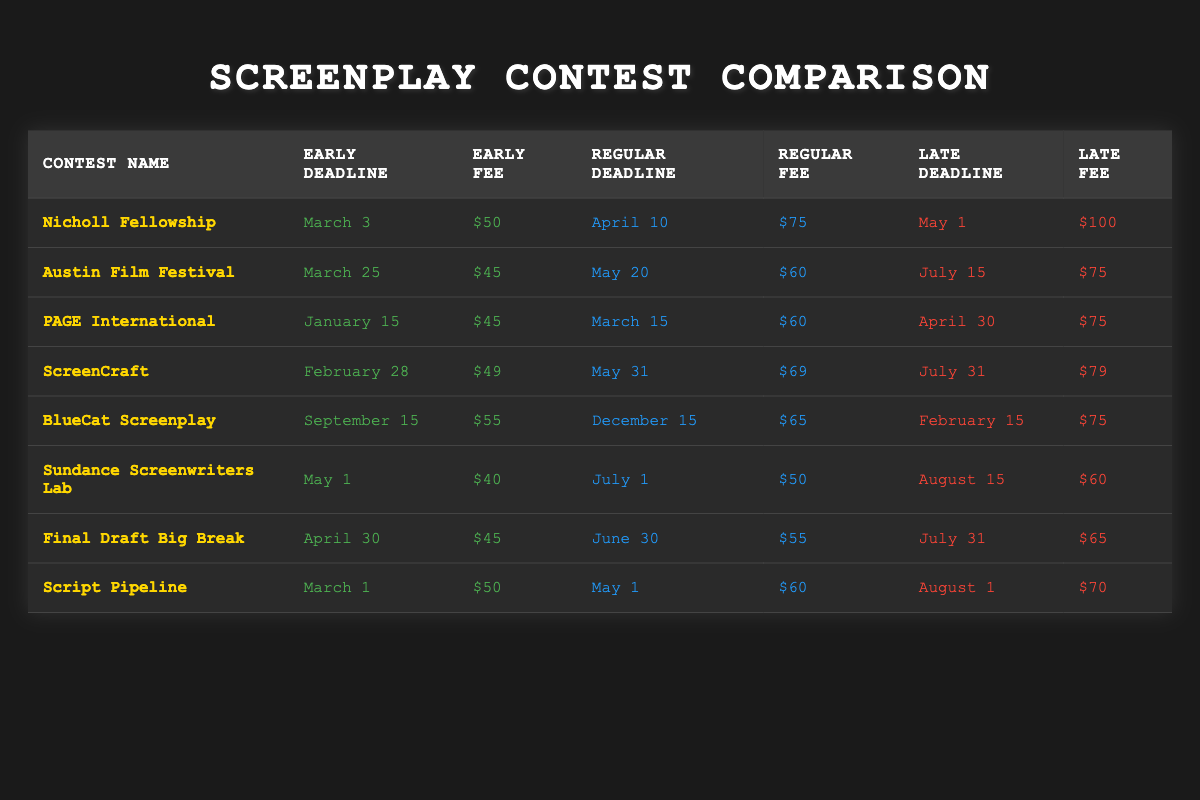What is the early fee for the Nicholl Fellowship? The early fee for the Nicholl Fellowship is explicitly stated in the table under the "Early Fee" column. It shows $50.
Answer: $50 Which contest has the latest regular deadline? I compare the "Regular Deadline" for all contests. The final contest listed, "BlueCat Screenplay," has a regular deadline of December 15, which is the latest compared to others.
Answer: BlueCat Screenplay Are there any contests with an early fee of $45? I look through the "Early Fee" column and see that both the Austin Film Festival and PAGE International have an early fee of $45, confirming that there are contests with this fee.
Answer: Yes What is the average late fee among all contests? I sum up all late fees: $100 + $75 + $75 + $79 + $75 + $60 + $65 + $70 = $699. There are 8 contests, so I divide the total by 8 to get the average: 699/8 = 87.375. Rounded to two decimal places, it's $87.38.
Answer: $87.38 Does the Sundance Screenwriters Lab have a cheaper early fee than the Final Draft Big Break? I compare the "Early Fee" for Sundance Screenwriters Lab ($40) with that of Final Draft Big Break ($45). Since $40 is less than $45, the statement is true.
Answer: Yes What is the difference between the early fee of PAGE International and the late fee of ScreenCraft? The early fee for PAGE International is $45, while the late fee for ScreenCraft is $79. I calculate the difference as follows: $79 - $45 = $34.
Answer: $34 Which contest has the lowest late fee? I review the "Late Fee" column to find the lowest value. The Sundance Screenwriters Lab has a late fee of $60, which is the lowest among all contests.
Answer: Sundance Screenwriters Lab How many contests have an early deadline in March? By examining the "Early Deadline" column, I find that three contests have early deadlines in March: Nicholl Fellowship (March 3), Austin Film Festival (March 25), and Script Pipeline (March 1). Thus, there are three contests.
Answer: 3 What is the late deadline for the Script Pipeline? I check the "Late Deadline" column for Script Pipeline and see that it is August 1.
Answer: August 1 